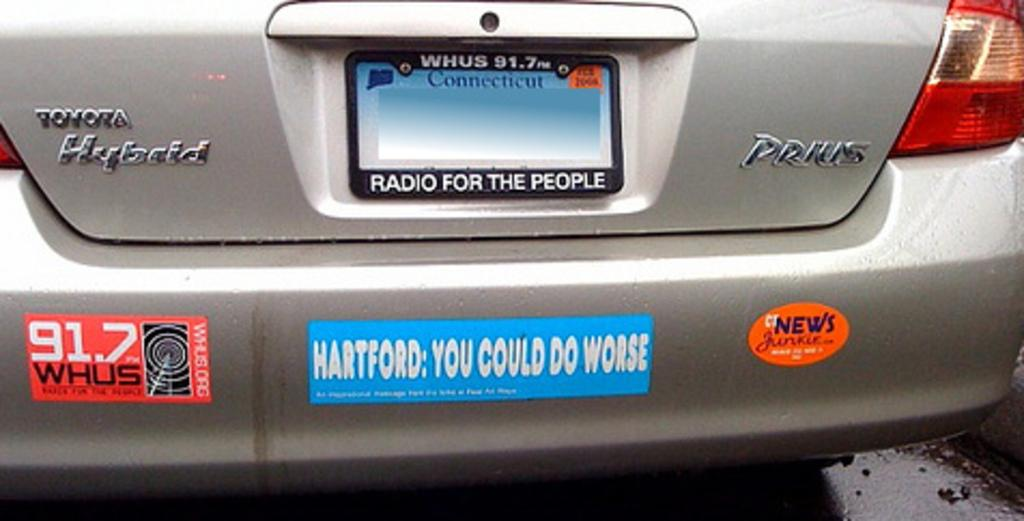<image>
Offer a succinct explanation of the picture presented. The bumper of a Toyota hybrid has a few bumper stickers. 